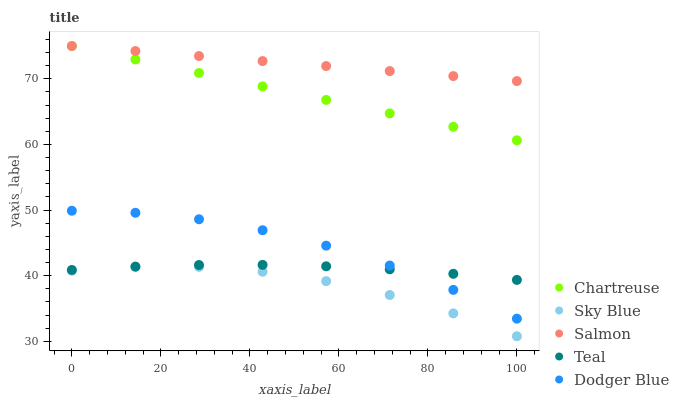Does Sky Blue have the minimum area under the curve?
Answer yes or no. Yes. Does Salmon have the maximum area under the curve?
Answer yes or no. Yes. Does Chartreuse have the minimum area under the curve?
Answer yes or no. No. Does Chartreuse have the maximum area under the curve?
Answer yes or no. No. Is Chartreuse the smoothest?
Answer yes or no. Yes. Is Sky Blue the roughest?
Answer yes or no. Yes. Is Salmon the smoothest?
Answer yes or no. No. Is Salmon the roughest?
Answer yes or no. No. Does Sky Blue have the lowest value?
Answer yes or no. Yes. Does Chartreuse have the lowest value?
Answer yes or no. No. Does Salmon have the highest value?
Answer yes or no. Yes. Does Teal have the highest value?
Answer yes or no. No. Is Dodger Blue less than Salmon?
Answer yes or no. Yes. Is Chartreuse greater than Sky Blue?
Answer yes or no. Yes. Does Teal intersect Sky Blue?
Answer yes or no. Yes. Is Teal less than Sky Blue?
Answer yes or no. No. Is Teal greater than Sky Blue?
Answer yes or no. No. Does Dodger Blue intersect Salmon?
Answer yes or no. No. 